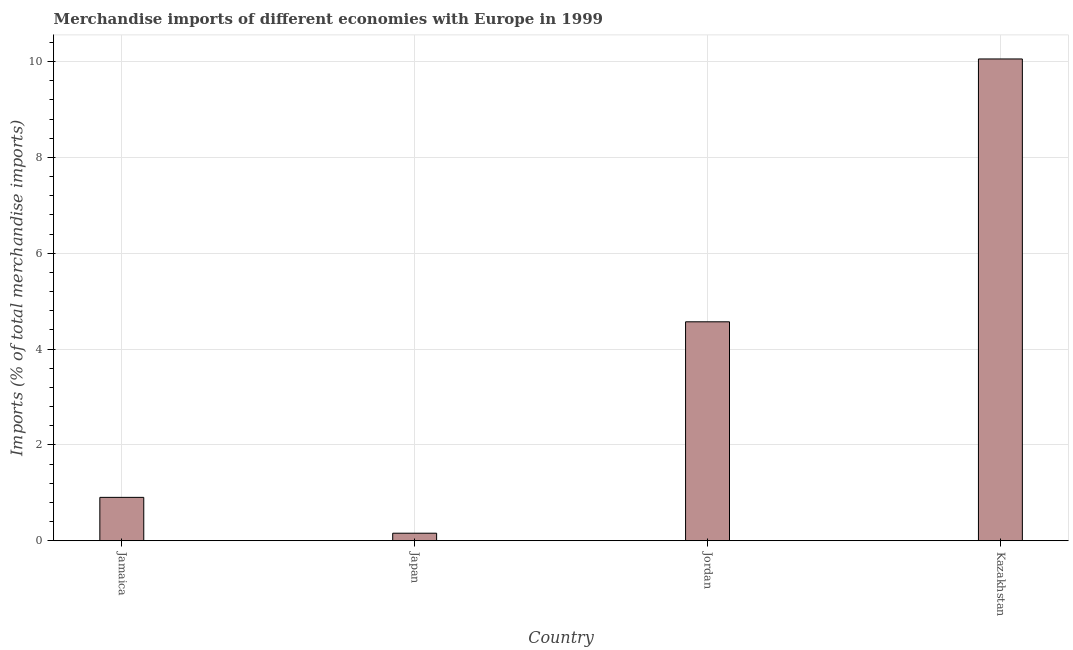What is the title of the graph?
Your answer should be very brief. Merchandise imports of different economies with Europe in 1999. What is the label or title of the X-axis?
Your answer should be compact. Country. What is the label or title of the Y-axis?
Your answer should be very brief. Imports (% of total merchandise imports). What is the merchandise imports in Kazakhstan?
Make the answer very short. 10.05. Across all countries, what is the maximum merchandise imports?
Your answer should be very brief. 10.05. Across all countries, what is the minimum merchandise imports?
Provide a succinct answer. 0.16. In which country was the merchandise imports maximum?
Keep it short and to the point. Kazakhstan. In which country was the merchandise imports minimum?
Give a very brief answer. Japan. What is the sum of the merchandise imports?
Ensure brevity in your answer.  15.68. What is the difference between the merchandise imports in Jamaica and Japan?
Your answer should be very brief. 0.75. What is the average merchandise imports per country?
Offer a very short reply. 3.92. What is the median merchandise imports?
Ensure brevity in your answer.  2.74. What is the ratio of the merchandise imports in Japan to that in Kazakhstan?
Provide a succinct answer. 0.02. What is the difference between the highest and the second highest merchandise imports?
Provide a succinct answer. 5.49. Is the sum of the merchandise imports in Jamaica and Jordan greater than the maximum merchandise imports across all countries?
Make the answer very short. No. What is the difference between the highest and the lowest merchandise imports?
Ensure brevity in your answer.  9.9. How many bars are there?
Offer a very short reply. 4. Are all the bars in the graph horizontal?
Your answer should be very brief. No. How many countries are there in the graph?
Make the answer very short. 4. What is the difference between two consecutive major ticks on the Y-axis?
Your answer should be very brief. 2. What is the Imports (% of total merchandise imports) of Jamaica?
Your answer should be compact. 0.9. What is the Imports (% of total merchandise imports) of Japan?
Provide a short and direct response. 0.16. What is the Imports (% of total merchandise imports) in Jordan?
Your answer should be compact. 4.57. What is the Imports (% of total merchandise imports) of Kazakhstan?
Your response must be concise. 10.05. What is the difference between the Imports (% of total merchandise imports) in Jamaica and Japan?
Offer a terse response. 0.75. What is the difference between the Imports (% of total merchandise imports) in Jamaica and Jordan?
Keep it short and to the point. -3.66. What is the difference between the Imports (% of total merchandise imports) in Jamaica and Kazakhstan?
Keep it short and to the point. -9.15. What is the difference between the Imports (% of total merchandise imports) in Japan and Jordan?
Your response must be concise. -4.41. What is the difference between the Imports (% of total merchandise imports) in Japan and Kazakhstan?
Make the answer very short. -9.9. What is the difference between the Imports (% of total merchandise imports) in Jordan and Kazakhstan?
Provide a succinct answer. -5.48. What is the ratio of the Imports (% of total merchandise imports) in Jamaica to that in Japan?
Your answer should be compact. 5.78. What is the ratio of the Imports (% of total merchandise imports) in Jamaica to that in Jordan?
Provide a succinct answer. 0.2. What is the ratio of the Imports (% of total merchandise imports) in Jamaica to that in Kazakhstan?
Provide a short and direct response. 0.09. What is the ratio of the Imports (% of total merchandise imports) in Japan to that in Jordan?
Your answer should be compact. 0.03. What is the ratio of the Imports (% of total merchandise imports) in Japan to that in Kazakhstan?
Your answer should be compact. 0.02. What is the ratio of the Imports (% of total merchandise imports) in Jordan to that in Kazakhstan?
Give a very brief answer. 0.45. 